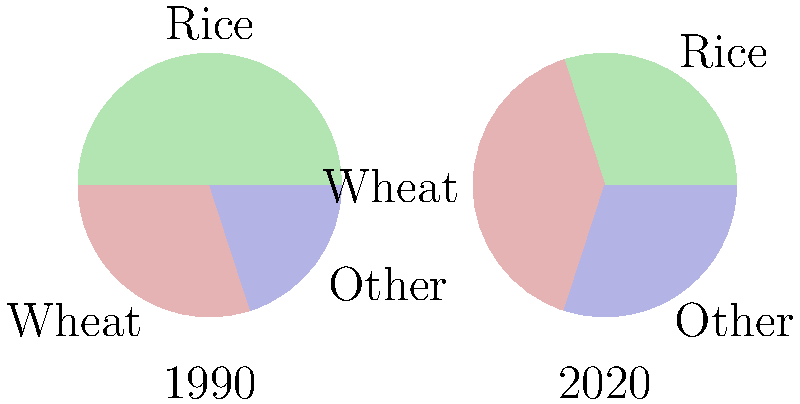The pie charts show the distribution of agricultural land use in Lalupura district for the years 1990 and 2020. Based on the data presented, calculate the percentage change in land used for wheat cultivation from 1990 to 2020. To calculate the percentage change in land used for wheat cultivation from 1990 to 2020, we need to follow these steps:

1. Identify the proportion of land used for wheat in 1990 and 2020:
   1990: 30% (0.3)
   2020: 40% (0.4)

2. Calculate the absolute change:
   Change = 2020 value - 1990 value
   Change = 0.4 - 0.3 = 0.1 (or 10 percentage points)

3. Calculate the percentage change:
   Percentage change = (Change / Original value) × 100
   Percentage change = (0.1 / 0.3) × 100
   Percentage change = 0.3333... × 100 = 33.33...%

4. Round the result to the nearest whole number:
   Percentage change ≈ 33%

Therefore, the percentage change in land used for wheat cultivation from 1990 to 2020 is approximately 33% increase.
Answer: 33% increase 